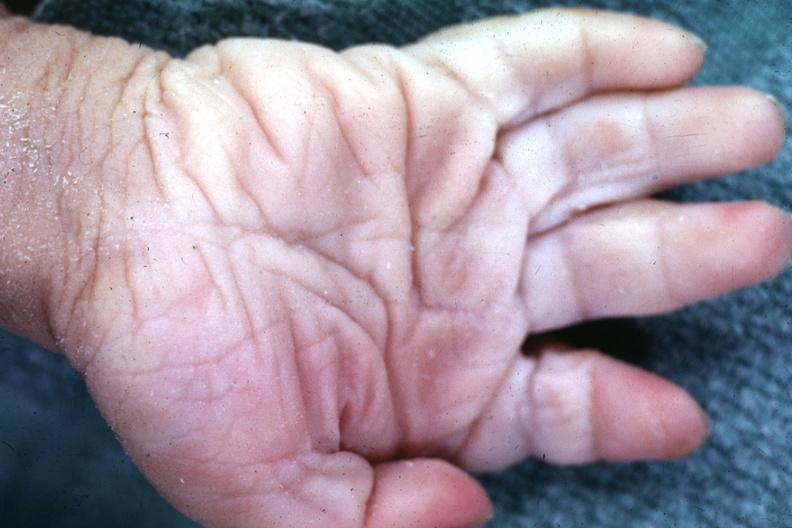what is present?
Answer the question using a single word or phrase. Hand 